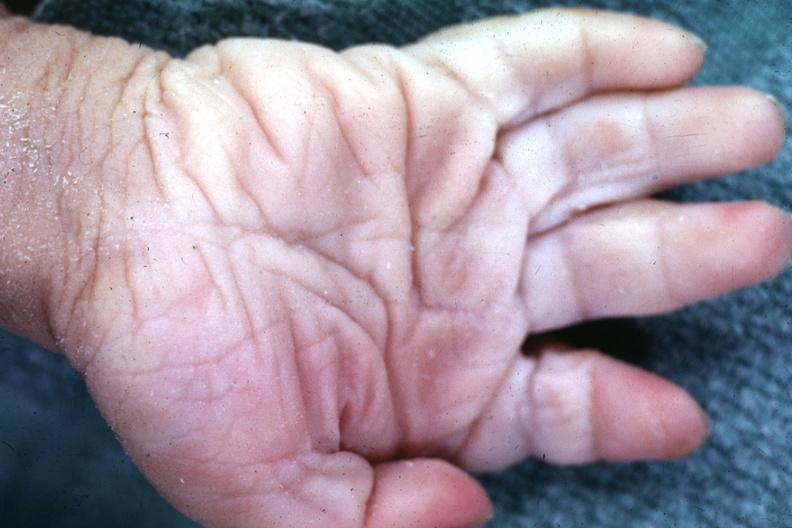what is present?
Answer the question using a single word or phrase. Hand 